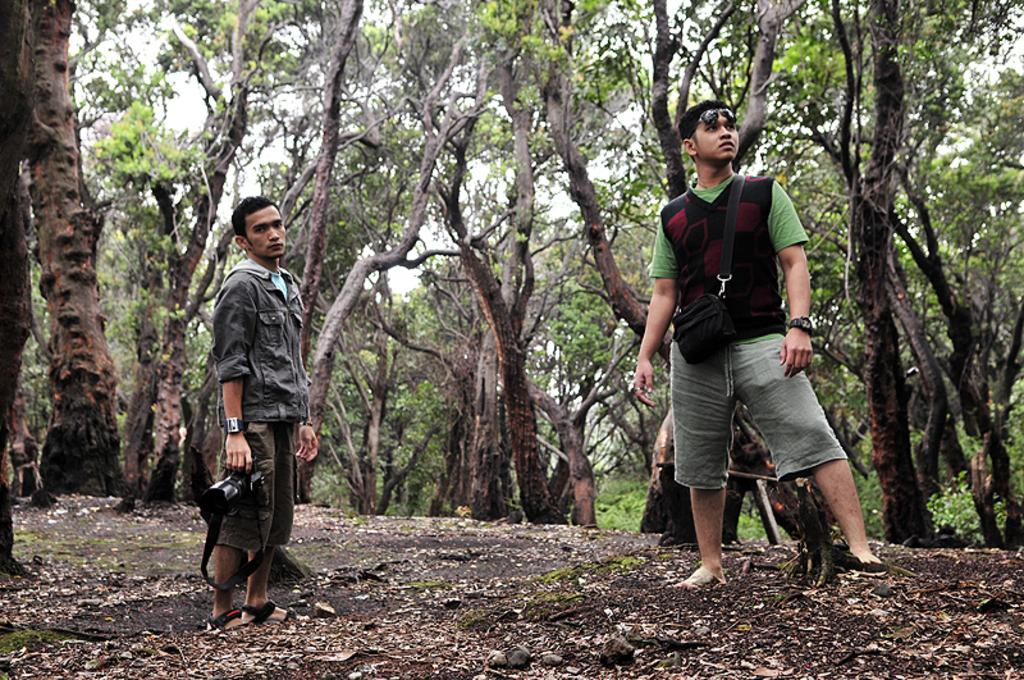How many people are in the image? There are two persons in the image. What is one of the persons holding? One person is holding a camera. What can be seen in the background behind the persons? Trees are visible behind the persons. What type of oil is being used to paint the canvas in the image? There is no canvas or oil present in the image; it features two persons and trees in the background. 